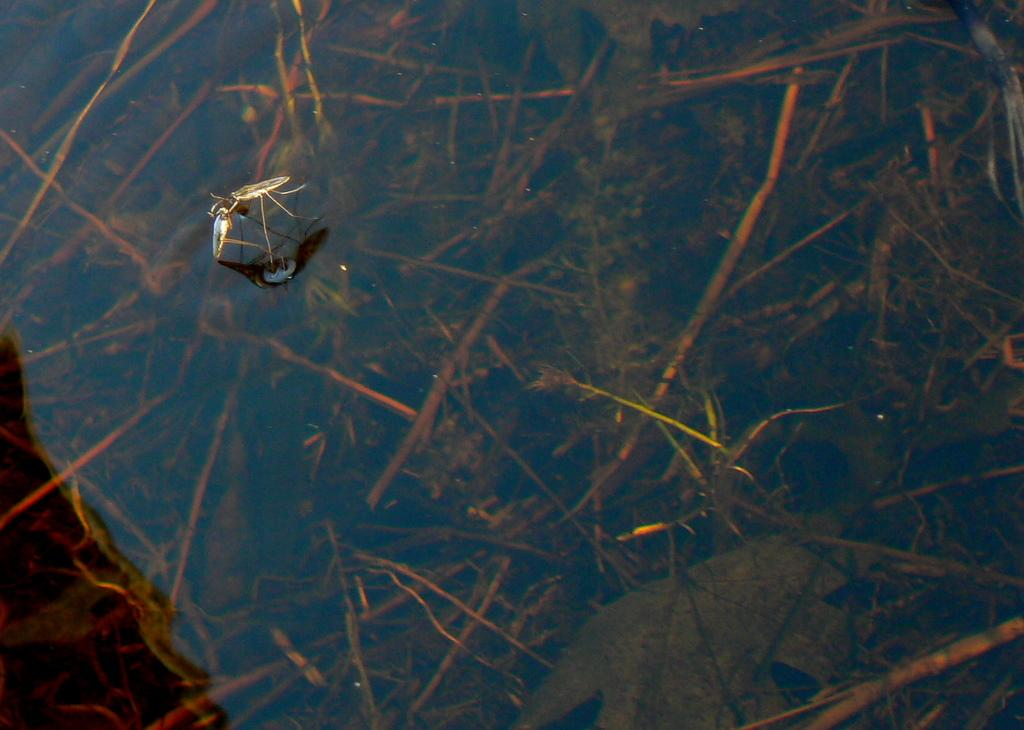What is in the water in the image? There is an insect in the water in the image. What is the primary element visible in the image? Water is visible in the image. Can you describe the background of the image? There is water visible in the background of the image. How does the insect aid in the digestion of food in the image? The image does not show the insect's digestive system or any food, so it is not possible to determine its role in digestion. 